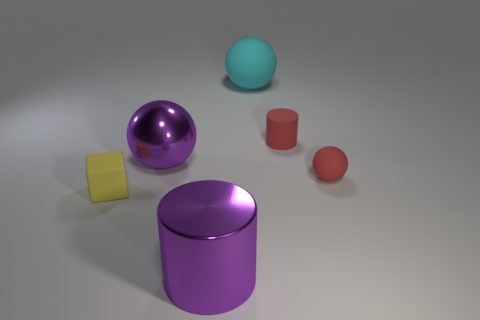Add 4 brown metallic balls. How many objects exist? 10 Subtract all cylinders. How many objects are left? 4 Subtract all green blocks. Subtract all metal cylinders. How many objects are left? 5 Add 6 purple cylinders. How many purple cylinders are left? 7 Add 1 small blue spheres. How many small blue spheres exist? 1 Subtract 1 red spheres. How many objects are left? 5 